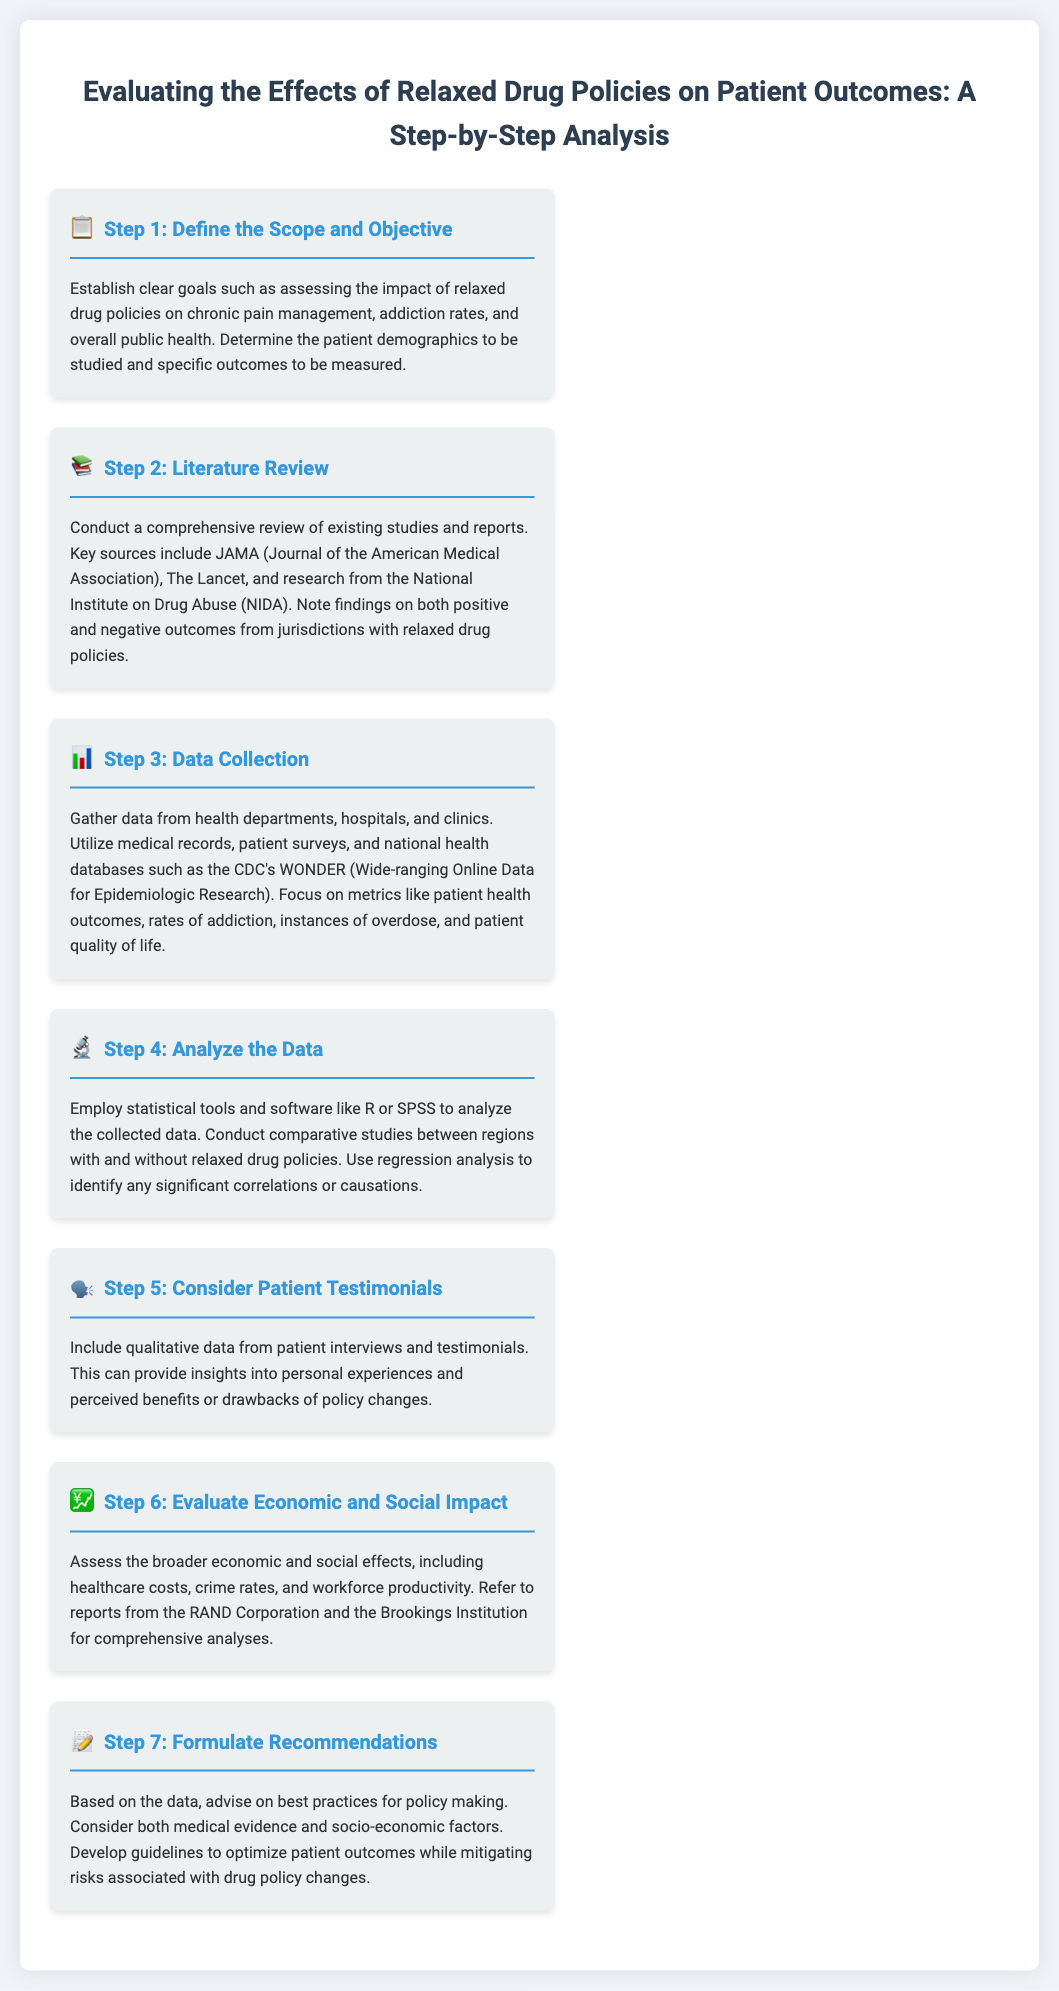What is the first step in the process? The first step involves establishing clear goals related to the impact of relaxed drug policies.
Answer: Define the Scope and Objective Which journals are mentioned for the literature review? The document lists specific journals important for the literature review process.
Answer: JAMA, The Lancet What tools are suggested for data analysis? The document recommends specific statistical tools for analyzing the collected data.
Answer: R or SPSS What type of data is included in patient testimonials? Patient testimonials provide qualitative insights about policy changes.
Answer: Qualitative data What types of effects are evaluated in the economic and social impact step? This step focuses on broader effects in specific categories.
Answer: Healthcare costs, crime rates, workforce productivity What is the final step outlined in the document? The last step provides a conclusion based on the findings of the analysis.
Answer: Formulate Recommendations How many steps are there in total? The document specifies the number of steps involved in the process.
Answer: Seven Which organization is mentioned as a source for economic analysis? The document refers to a specific institution for economic assessments in the context of drug policies.
Answer: RAND Corporation 